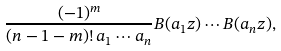Convert formula to latex. <formula><loc_0><loc_0><loc_500><loc_500>\frac { ( - 1 ) ^ { m } } { ( n - 1 - m ) ! \, a _ { 1 } \cdots a _ { n } } B ( a _ { 1 } z ) \cdots B ( a _ { n } z ) ,</formula> 